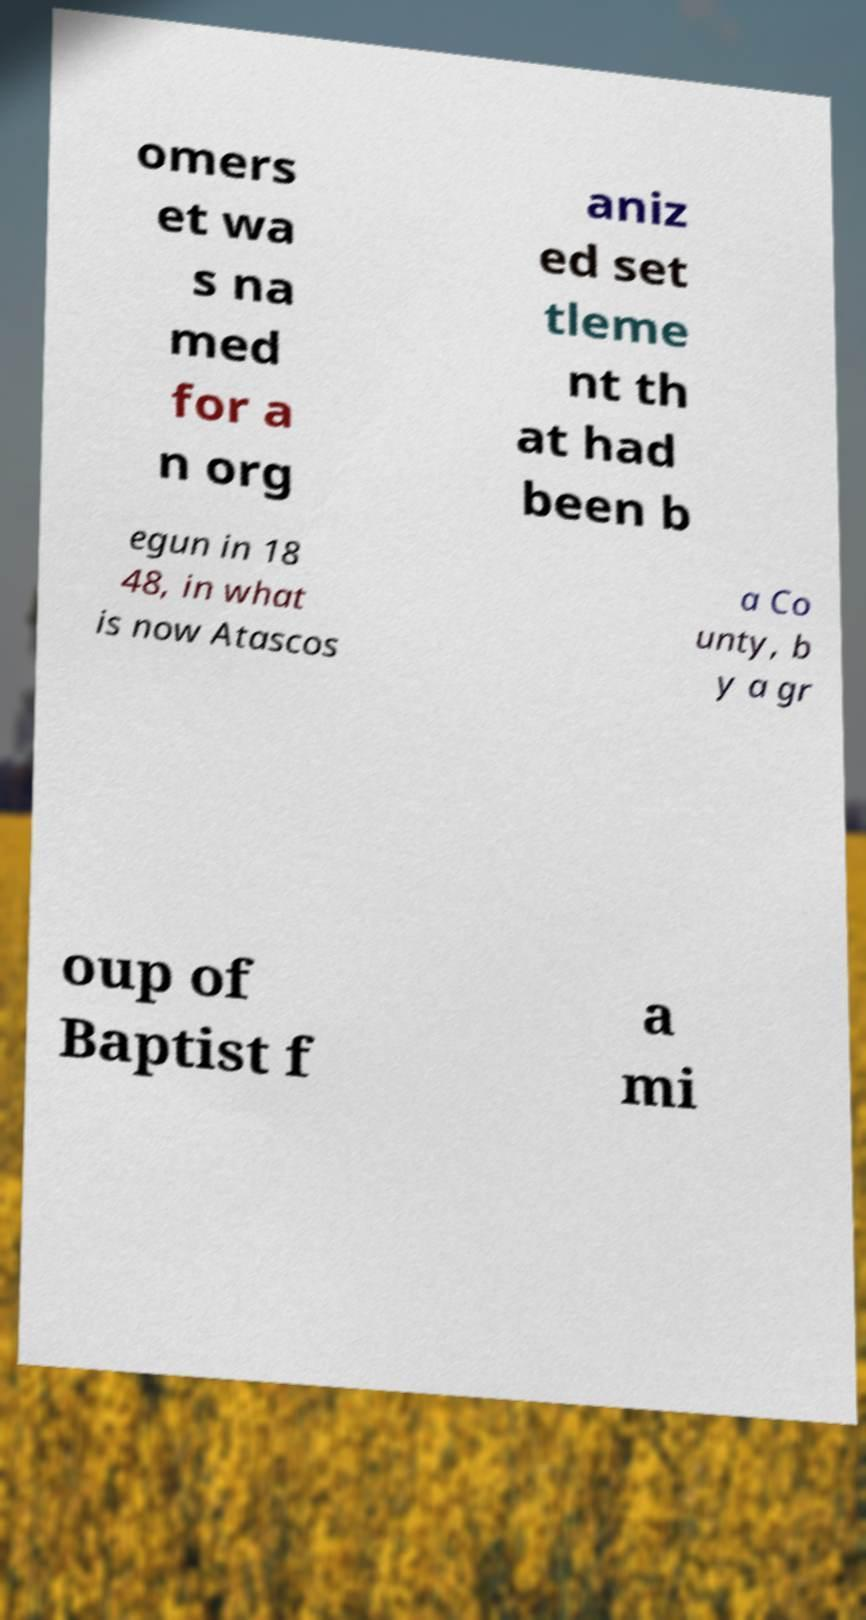For documentation purposes, I need the text within this image transcribed. Could you provide that? omers et wa s na med for a n org aniz ed set tleme nt th at had been b egun in 18 48, in what is now Atascos a Co unty, b y a gr oup of Baptist f a mi 